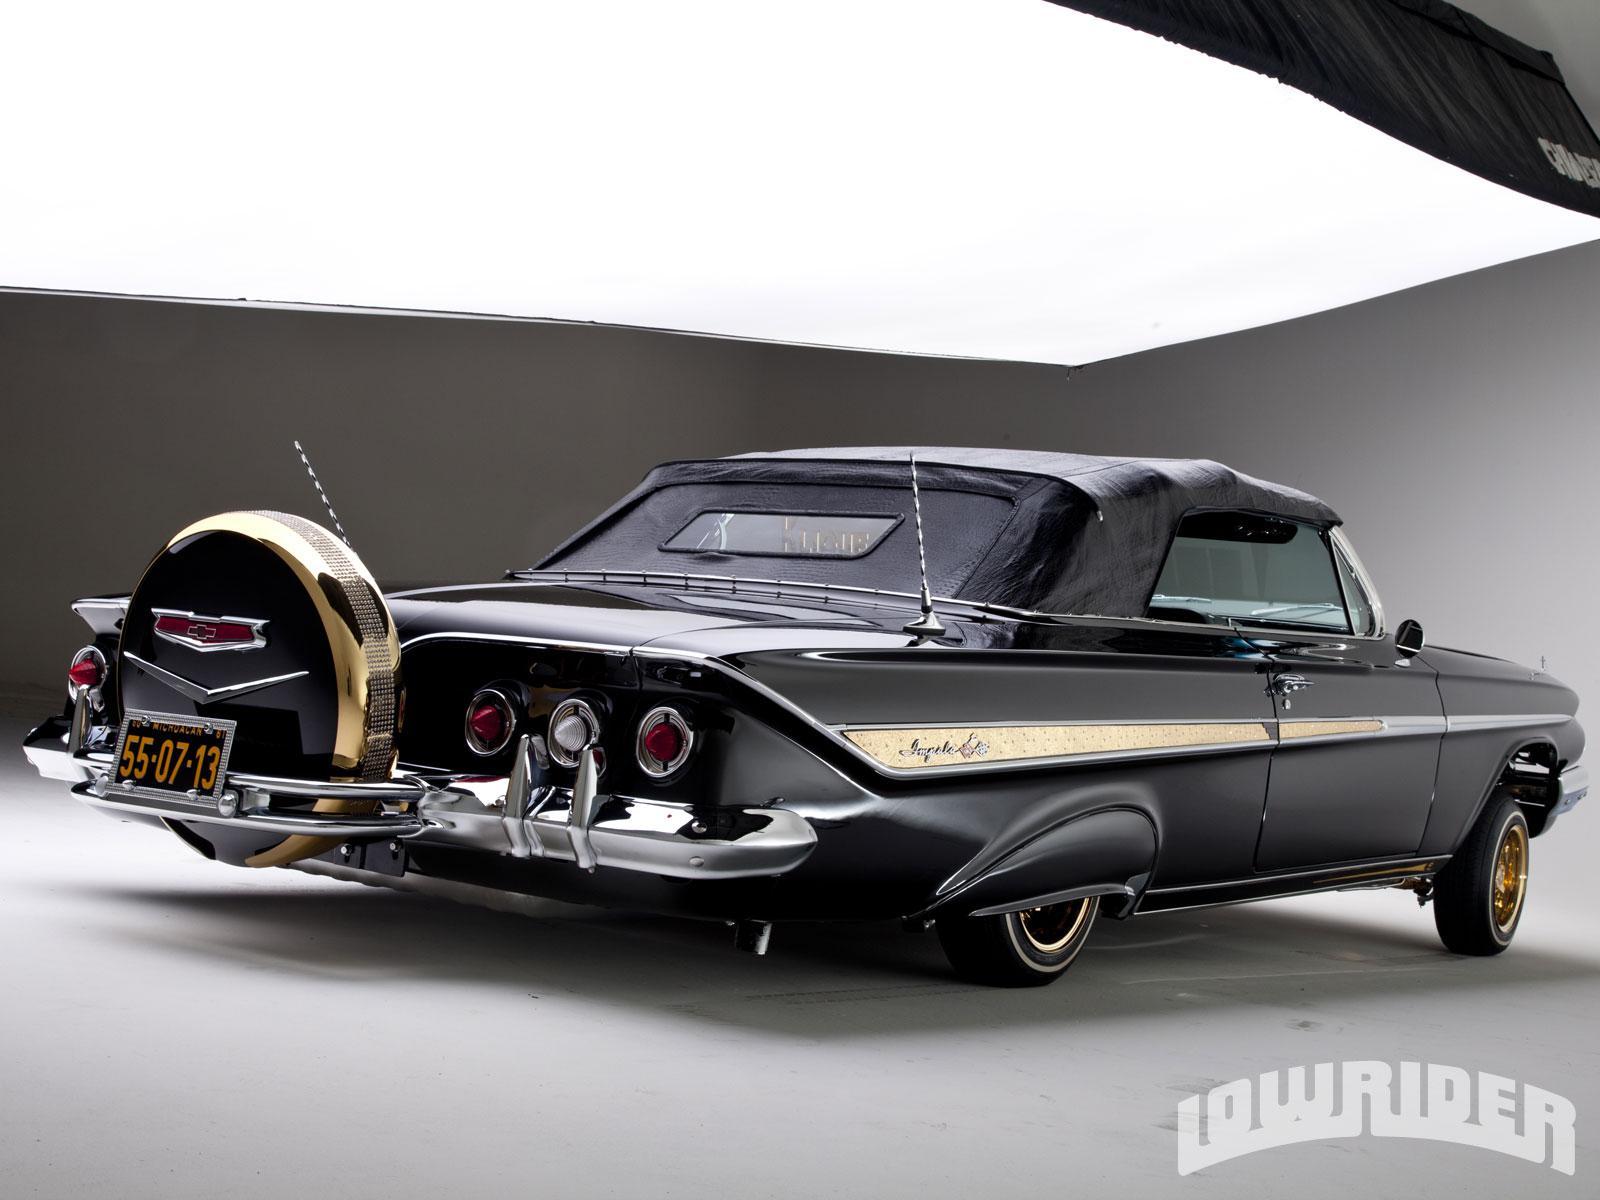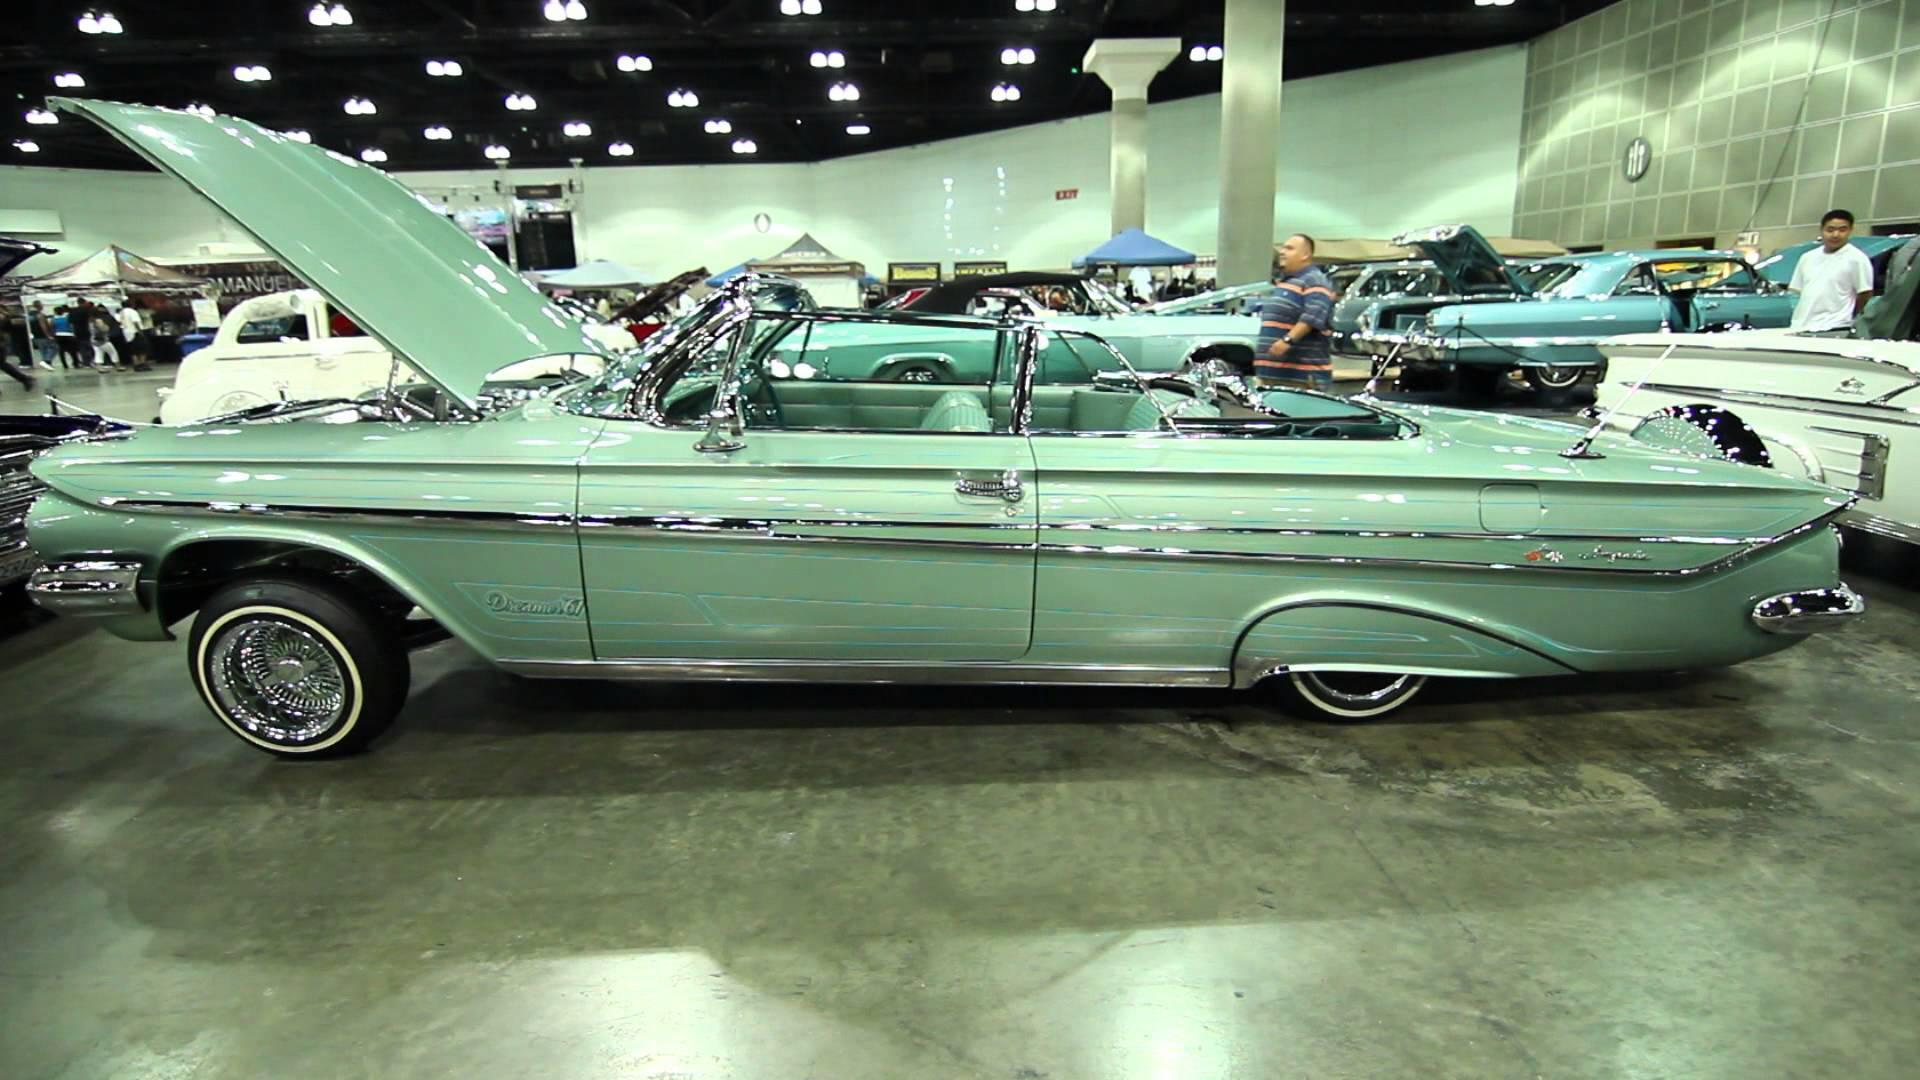The first image is the image on the left, the second image is the image on the right. Given the left and right images, does the statement "The car in the image on the right has their convertible top open." hold true? Answer yes or no. Yes. The first image is the image on the left, the second image is the image on the right. Given the left and right images, does the statement "In one image part of the car is open." hold true? Answer yes or no. Yes. 